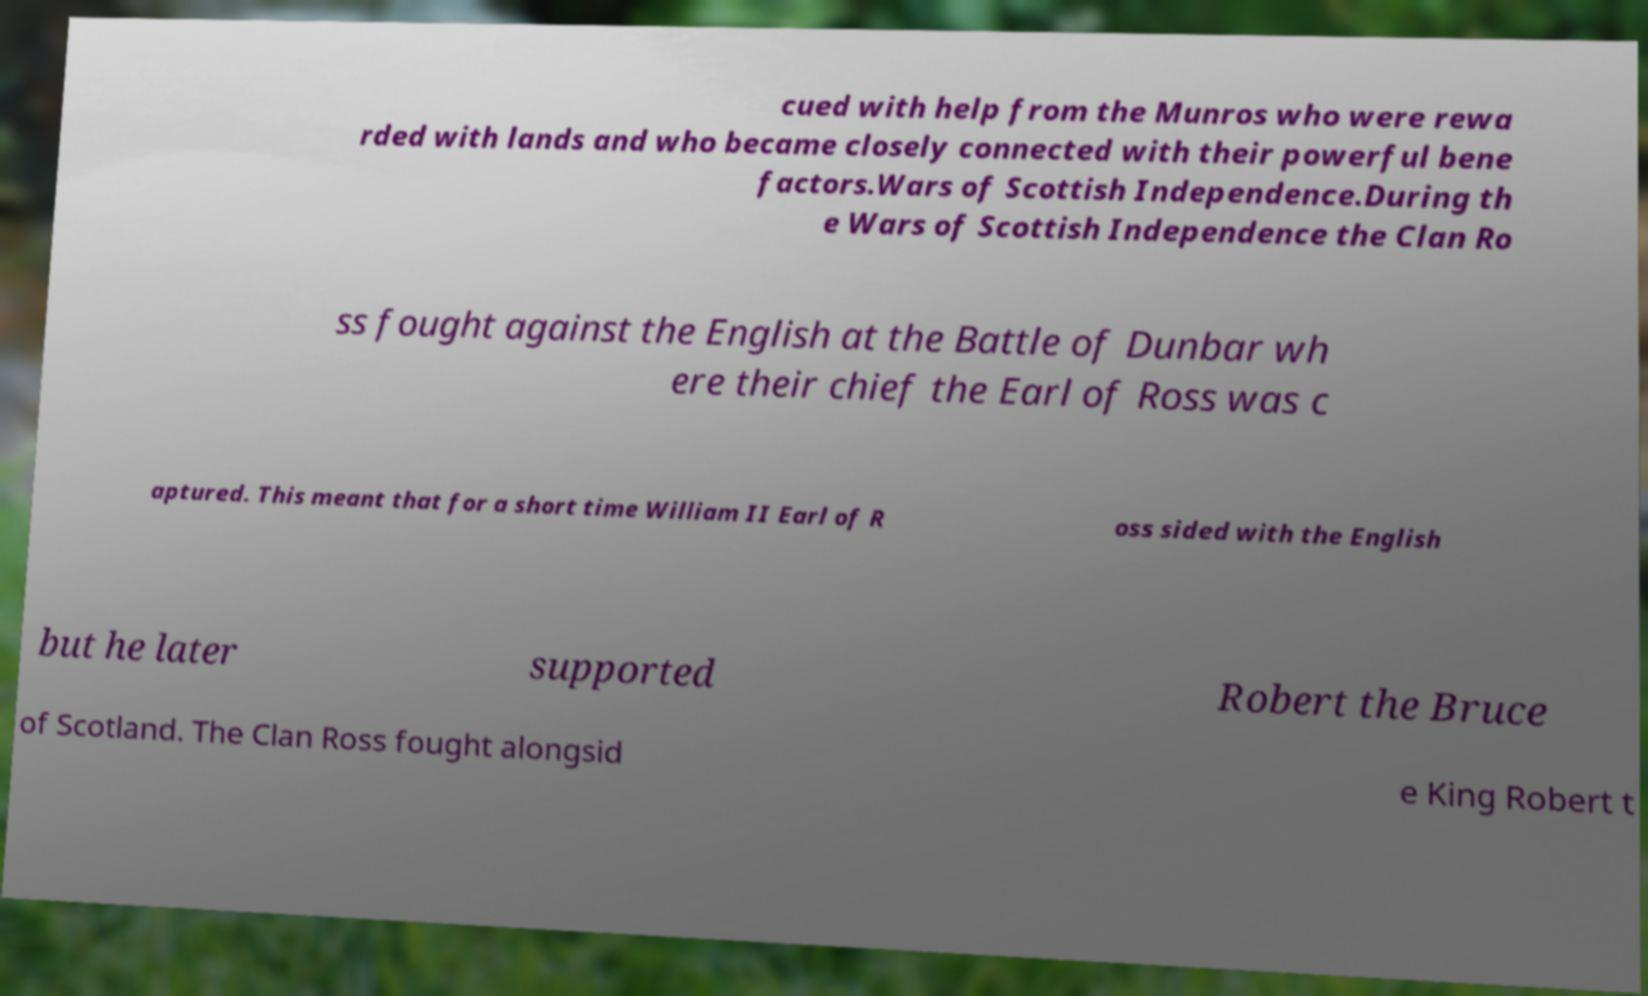Please identify and transcribe the text found in this image. cued with help from the Munros who were rewa rded with lands and who became closely connected with their powerful bene factors.Wars of Scottish Independence.During th e Wars of Scottish Independence the Clan Ro ss fought against the English at the Battle of Dunbar wh ere their chief the Earl of Ross was c aptured. This meant that for a short time William II Earl of R oss sided with the English but he later supported Robert the Bruce of Scotland. The Clan Ross fought alongsid e King Robert t 